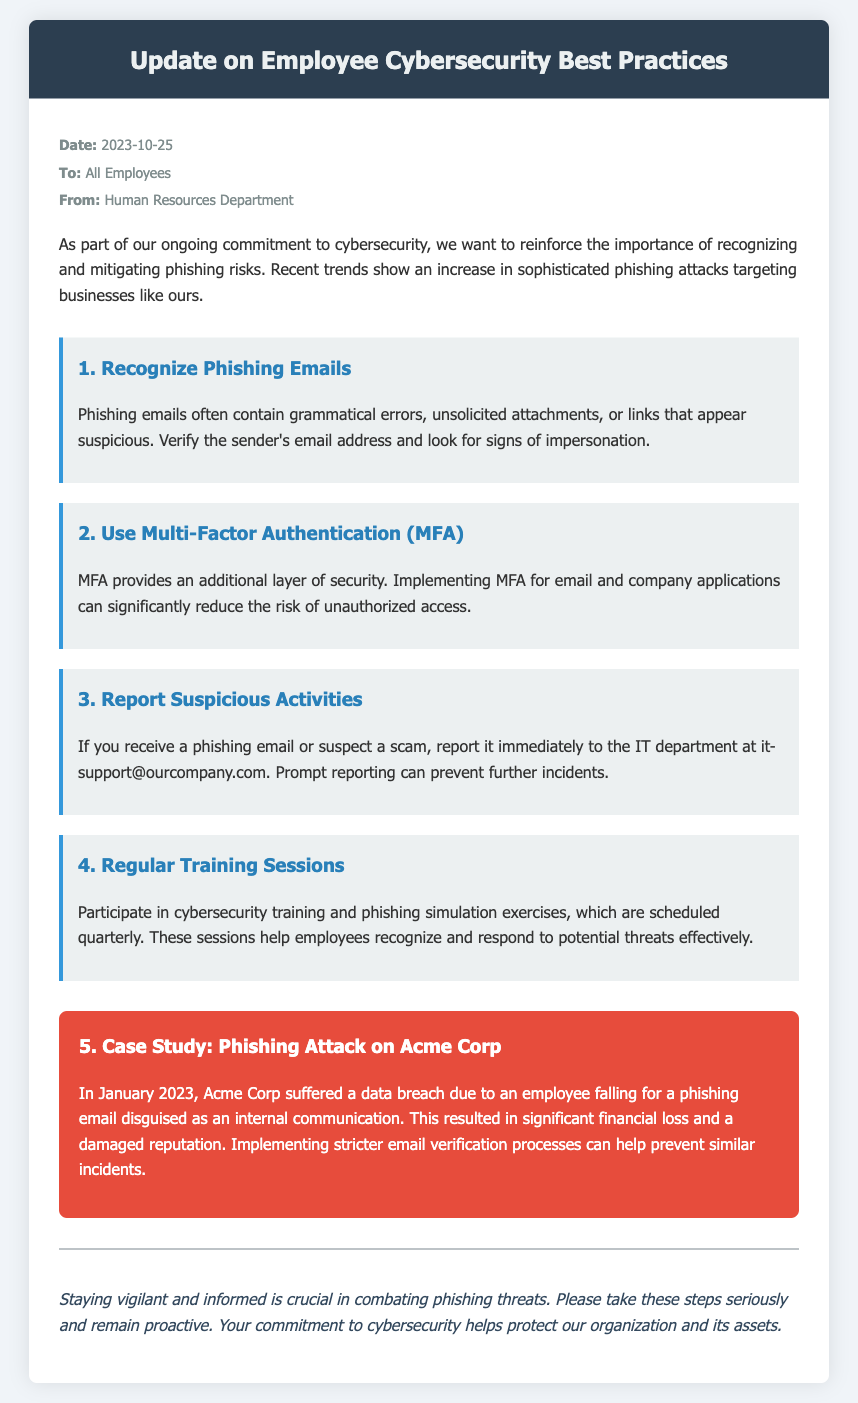What is the date of the memo? The date mentioned in the memo is the publication date of the document, which is 2023-10-25.
Answer: 2023-10-25 Who is the memo addressed to? The memo is addressed to all employees as stated in the document.
Answer: All Employees What should employees do if they receive a phishing email? The document states that employees should report phishing emails immediately to the IT department.
Answer: Report it immediately to the IT department What type of authentication is recommended in the memo? The memo recommends implementing multi-factor authentication for additional security.
Answer: Multi-Factor Authentication (MFA) What incident is highlighted in the case study? The case study details a phishing attack on Acme Corp that led to a data breach due to an employee falling for a phishing email.
Answer: A phishing attack on Acme Corp How often are cybersecurity training sessions scheduled? The document mentions that training sessions are scheduled quarterly.
Answer: Quarterly What is a common sign of phishing emails according to the memo? One common sign of phishing emails mentioned is grammatical errors.
Answer: Grammatical errors What is the aim of the memo? The purpose of the memo is to update employees on cybersecurity best practices and mitigate phishing risks.
Answer: To update on cybersecurity best practices 